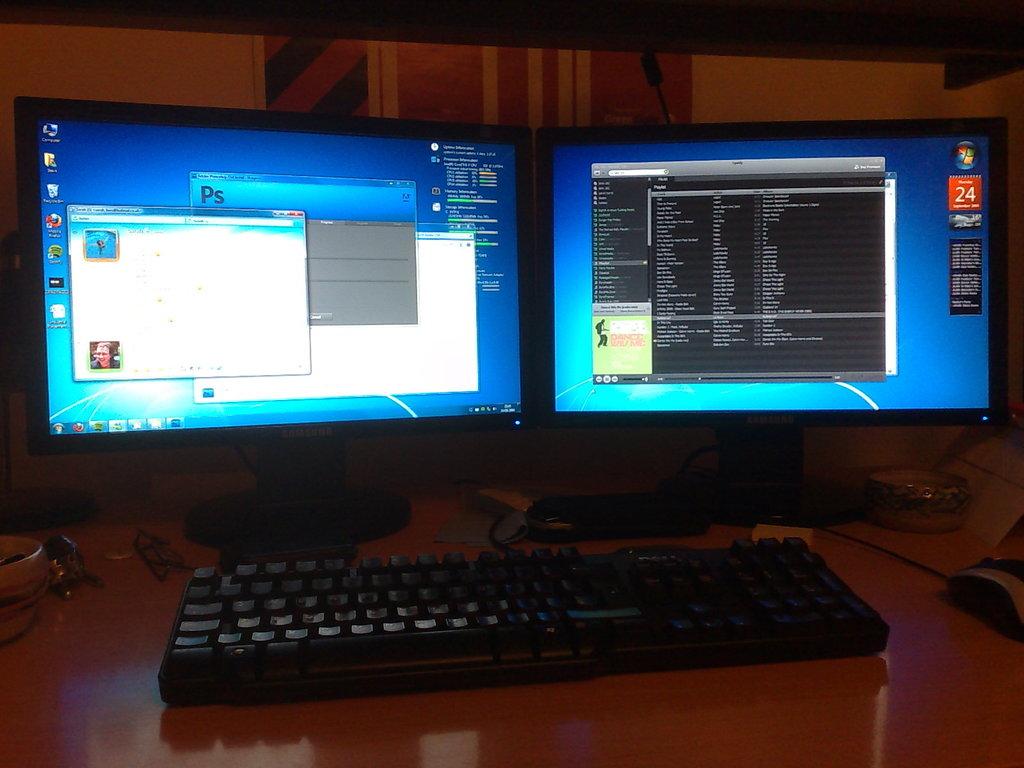What letters are on the middle block?
Keep it short and to the point. Ps. 